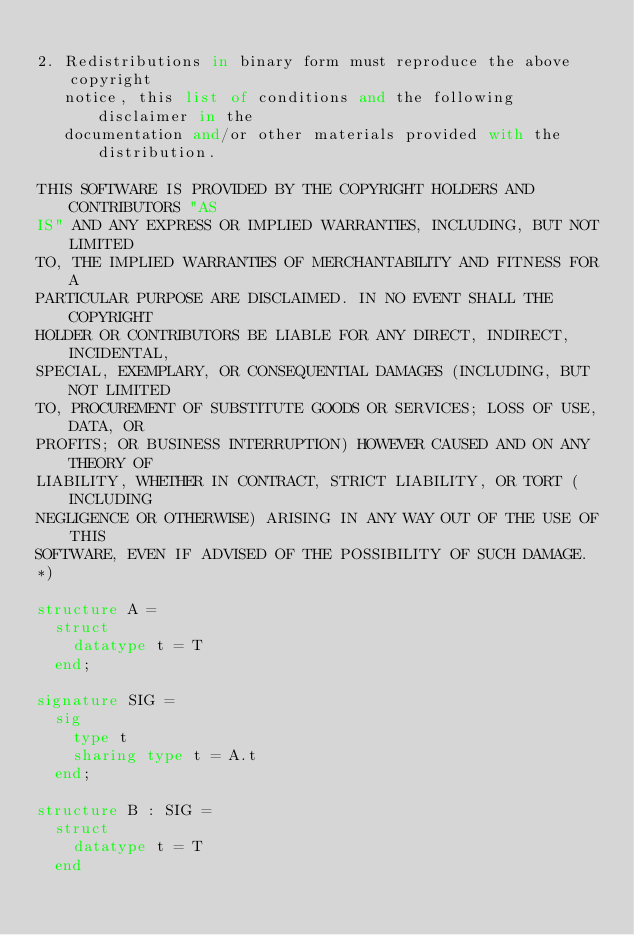Convert code to text. <code><loc_0><loc_0><loc_500><loc_500><_SML_>
2. Redistributions in binary form must reproduce the above copyright
   notice, this list of conditions and the following disclaimer in the
   documentation and/or other materials provided with the distribution.

THIS SOFTWARE IS PROVIDED BY THE COPYRIGHT HOLDERS AND CONTRIBUTORS "AS
IS" AND ANY EXPRESS OR IMPLIED WARRANTIES, INCLUDING, BUT NOT LIMITED
TO, THE IMPLIED WARRANTIES OF MERCHANTABILITY AND FITNESS FOR A
PARTICULAR PURPOSE ARE DISCLAIMED. IN NO EVENT SHALL THE COPYRIGHT
HOLDER OR CONTRIBUTORS BE LIABLE FOR ANY DIRECT, INDIRECT, INCIDENTAL,
SPECIAL, EXEMPLARY, OR CONSEQUENTIAL DAMAGES (INCLUDING, BUT NOT LIMITED
TO, PROCUREMENT OF SUBSTITUTE GOODS OR SERVICES; LOSS OF USE, DATA, OR
PROFITS; OR BUSINESS INTERRUPTION) HOWEVER CAUSED AND ON ANY THEORY OF
LIABILITY, WHETHER IN CONTRACT, STRICT LIABILITY, OR TORT (INCLUDING
NEGLIGENCE OR OTHERWISE) ARISING IN ANY WAY OUT OF THE USE OF THIS
SOFTWARE, EVEN IF ADVISED OF THE POSSIBILITY OF SUCH DAMAGE.
*)

structure A = 
  struct
    datatype t = T
  end;

signature SIG = 
  sig
    type t
    sharing type t = A.t
  end;

structure B : SIG = 
  struct
    datatype t = T
  end
</code> 